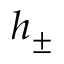Convert formula to latex. <formula><loc_0><loc_0><loc_500><loc_500>h _ { \pm }</formula> 